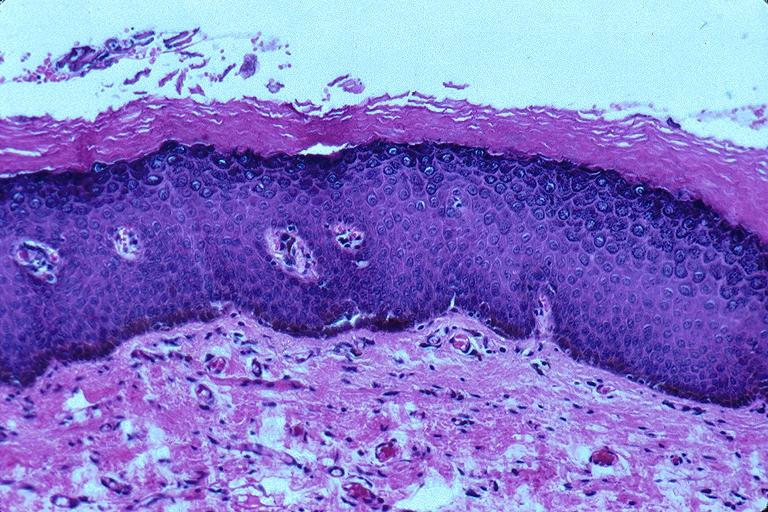what is present?
Answer the question using a single word or phrase. Oral 